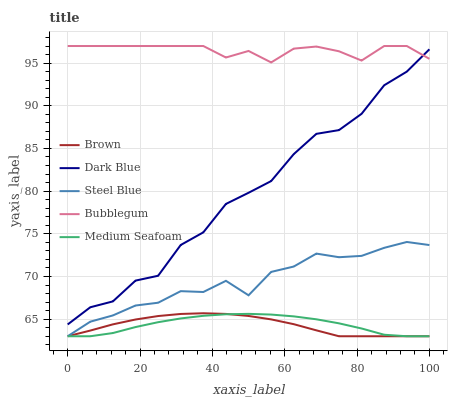Does Medium Seafoam have the minimum area under the curve?
Answer yes or no. No. Does Medium Seafoam have the maximum area under the curve?
Answer yes or no. No. Is Medium Seafoam the smoothest?
Answer yes or no. No. Is Medium Seafoam the roughest?
Answer yes or no. No. Does Bubblegum have the lowest value?
Answer yes or no. No. Does Steel Blue have the highest value?
Answer yes or no. No. Is Medium Seafoam less than Bubblegum?
Answer yes or no. Yes. Is Dark Blue greater than Brown?
Answer yes or no. Yes. Does Medium Seafoam intersect Bubblegum?
Answer yes or no. No. 